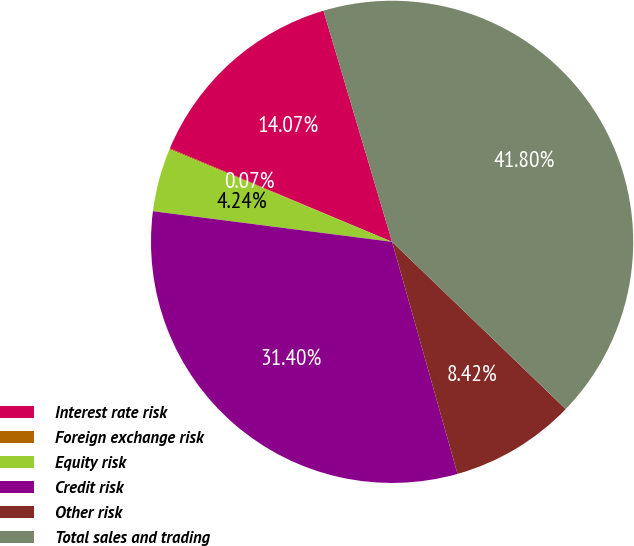Convert chart. <chart><loc_0><loc_0><loc_500><loc_500><pie_chart><fcel>Interest rate risk<fcel>Foreign exchange risk<fcel>Equity risk<fcel>Credit risk<fcel>Other risk<fcel>Total sales and trading<nl><fcel>14.07%<fcel>0.07%<fcel>4.24%<fcel>31.4%<fcel>8.42%<fcel>41.8%<nl></chart> 